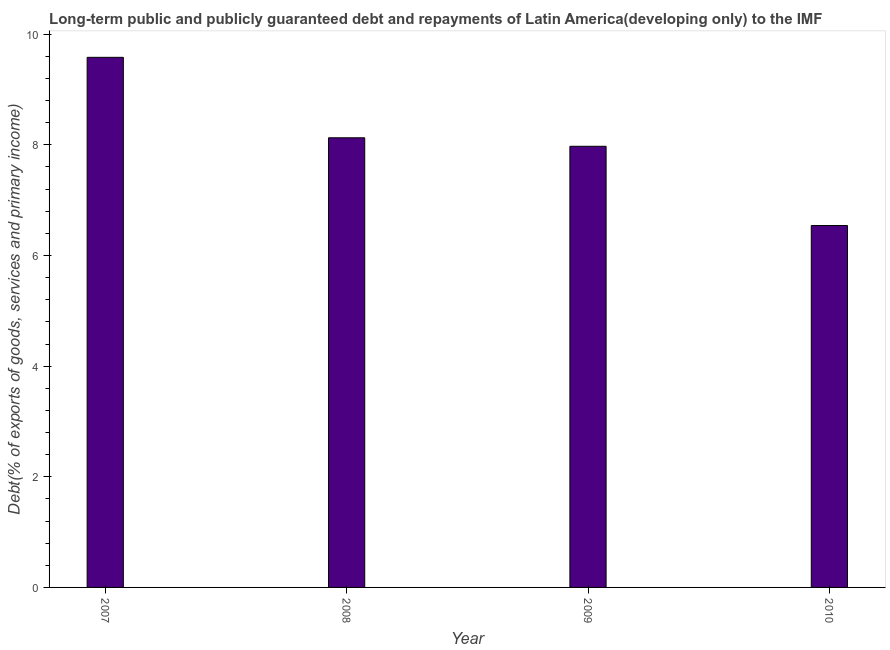What is the title of the graph?
Ensure brevity in your answer.  Long-term public and publicly guaranteed debt and repayments of Latin America(developing only) to the IMF. What is the label or title of the Y-axis?
Keep it short and to the point. Debt(% of exports of goods, services and primary income). What is the debt service in 2008?
Your answer should be compact. 8.13. Across all years, what is the maximum debt service?
Make the answer very short. 9.58. Across all years, what is the minimum debt service?
Your answer should be compact. 6.54. In which year was the debt service minimum?
Provide a short and direct response. 2010. What is the sum of the debt service?
Provide a short and direct response. 32.22. What is the difference between the debt service in 2008 and 2010?
Give a very brief answer. 1.59. What is the average debt service per year?
Provide a short and direct response. 8.06. What is the median debt service?
Ensure brevity in your answer.  8.05. What is the ratio of the debt service in 2007 to that in 2010?
Make the answer very short. 1.47. Is the debt service in 2007 less than that in 2009?
Ensure brevity in your answer.  No. What is the difference between the highest and the second highest debt service?
Keep it short and to the point. 1.45. Is the sum of the debt service in 2007 and 2008 greater than the maximum debt service across all years?
Your answer should be compact. Yes. What is the difference between the highest and the lowest debt service?
Offer a very short reply. 3.04. In how many years, is the debt service greater than the average debt service taken over all years?
Give a very brief answer. 2. How many years are there in the graph?
Your answer should be very brief. 4. Are the values on the major ticks of Y-axis written in scientific E-notation?
Your response must be concise. No. What is the Debt(% of exports of goods, services and primary income) of 2007?
Offer a terse response. 9.58. What is the Debt(% of exports of goods, services and primary income) of 2008?
Offer a very short reply. 8.13. What is the Debt(% of exports of goods, services and primary income) in 2009?
Your answer should be very brief. 7.97. What is the Debt(% of exports of goods, services and primary income) in 2010?
Give a very brief answer. 6.54. What is the difference between the Debt(% of exports of goods, services and primary income) in 2007 and 2008?
Your answer should be very brief. 1.45. What is the difference between the Debt(% of exports of goods, services and primary income) in 2007 and 2009?
Your answer should be compact. 1.61. What is the difference between the Debt(% of exports of goods, services and primary income) in 2007 and 2010?
Offer a very short reply. 3.04. What is the difference between the Debt(% of exports of goods, services and primary income) in 2008 and 2009?
Offer a terse response. 0.15. What is the difference between the Debt(% of exports of goods, services and primary income) in 2008 and 2010?
Ensure brevity in your answer.  1.59. What is the difference between the Debt(% of exports of goods, services and primary income) in 2009 and 2010?
Your answer should be compact. 1.43. What is the ratio of the Debt(% of exports of goods, services and primary income) in 2007 to that in 2008?
Give a very brief answer. 1.18. What is the ratio of the Debt(% of exports of goods, services and primary income) in 2007 to that in 2009?
Offer a very short reply. 1.2. What is the ratio of the Debt(% of exports of goods, services and primary income) in 2007 to that in 2010?
Make the answer very short. 1.47. What is the ratio of the Debt(% of exports of goods, services and primary income) in 2008 to that in 2009?
Make the answer very short. 1.02. What is the ratio of the Debt(% of exports of goods, services and primary income) in 2008 to that in 2010?
Ensure brevity in your answer.  1.24. What is the ratio of the Debt(% of exports of goods, services and primary income) in 2009 to that in 2010?
Provide a short and direct response. 1.22. 